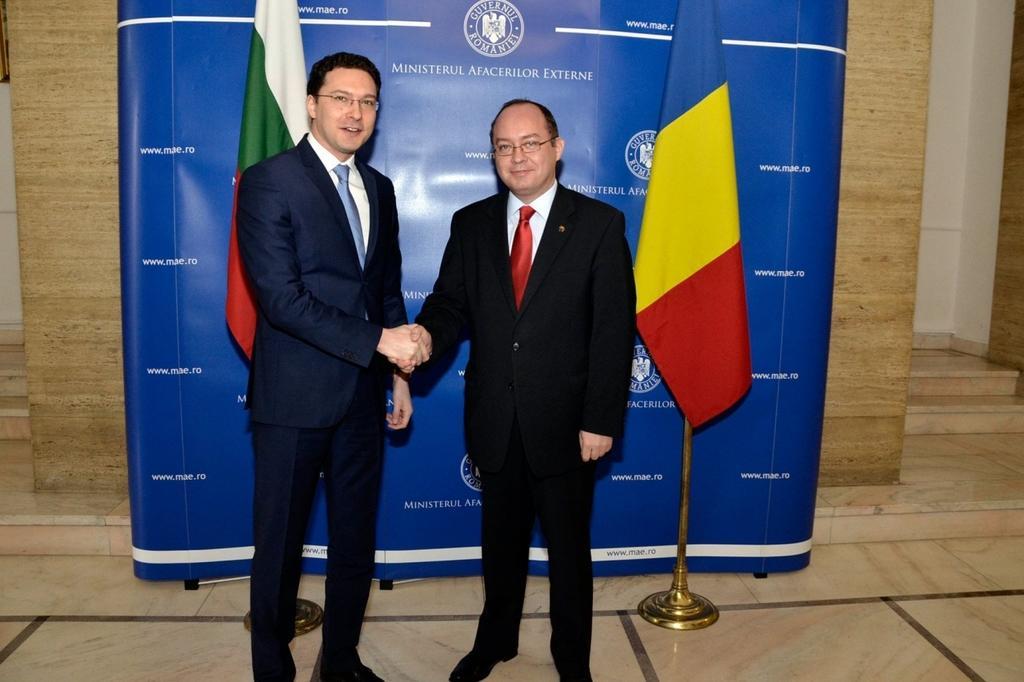How would you summarize this image in a sentence or two? This picture is clicked inside. In the center there are two men wearing suits, spectacles, standing on the ground and shaking their hands. In the background we can see the two flags of different colors and there is a blue color banner on which the text is printed and we can see the stairs and the wall. 